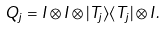<formula> <loc_0><loc_0><loc_500><loc_500>Q _ { j } = I \otimes I \otimes | T _ { j } \rangle \langle { T _ { j } } | \otimes I .</formula> 